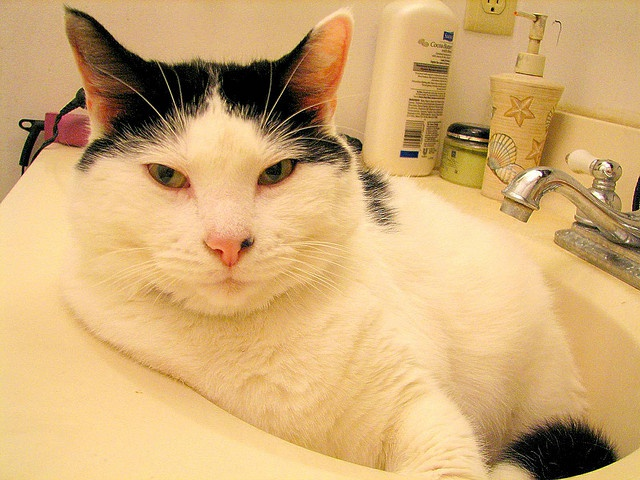Describe the objects in this image and their specific colors. I can see cat in tan and black tones, sink in tan tones, bottle in tan and olive tones, and bottle in tan, orange, and olive tones in this image. 